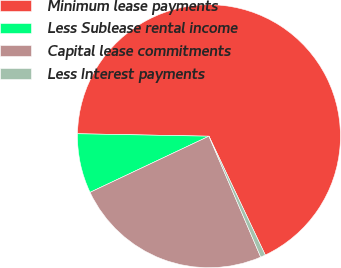Convert chart to OTSL. <chart><loc_0><loc_0><loc_500><loc_500><pie_chart><fcel>Minimum lease payments<fcel>Less Sublease rental income<fcel>Capital lease commitments<fcel>Less Interest payments<nl><fcel>67.66%<fcel>7.32%<fcel>24.42%<fcel>0.61%<nl></chart> 